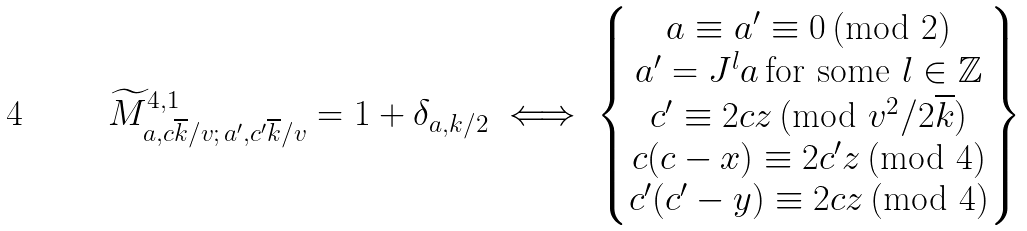<formula> <loc_0><loc_0><loc_500><loc_500>\widetilde { M } ^ { 4 , 1 } _ { a , c \overline { k } / v ; \, a ^ { \prime } , c ^ { \prime } \overline { k } / v } = 1 + \delta _ { a , k / 2 } \iff \left \{ \begin{matrix} a \equiv a ^ { \prime } \equiv 0 \, \text {(mod } 2 ) \\ a ^ { \prime } = J ^ { l } a \, \text {for some } l \in \mathbb { Z } \\ c ^ { \prime } \equiv 2 c z \, \text {(mod } v ^ { 2 } / 2 \overline { k } ) \\ c ( c - x ) \equiv 2 c ^ { \prime } z \, \text {(mod } 4 ) \\ c ^ { \prime } ( c ^ { \prime } - y ) \equiv 2 c z \, \text {(mod } 4 ) \end{matrix} \right \}</formula> 